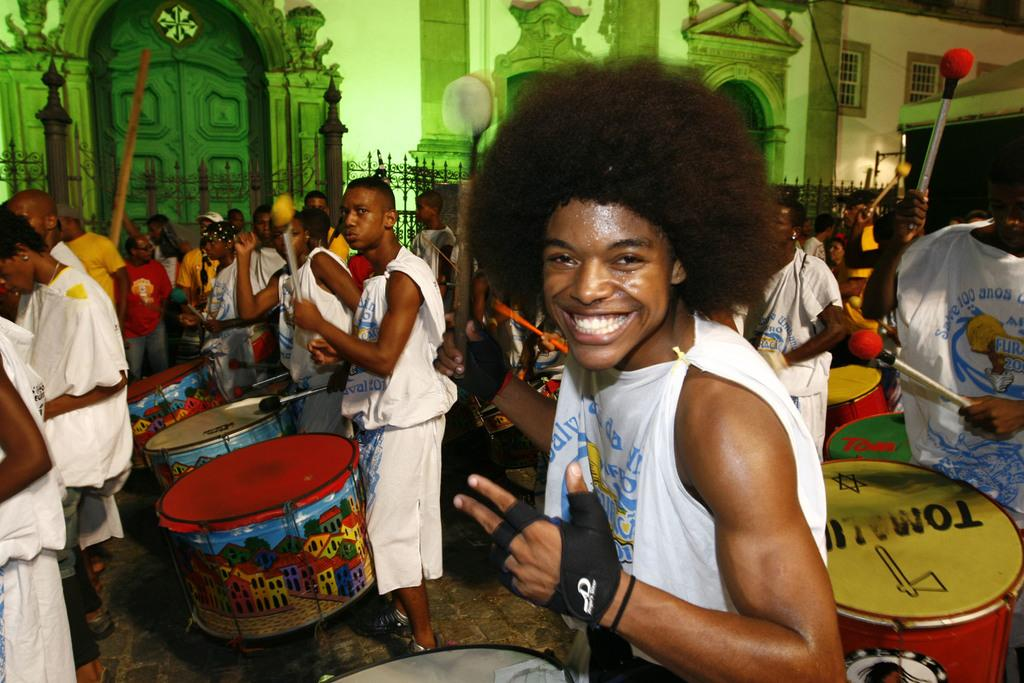What type of structure can be seen in the background of the image? There is a house with windows in the background. What is a prominent feature of the house? There is a door visible in the image. What are the people in the image doing? The people are standing and playing drums. Where are the people located in relation to the building? The people are in front of a building. Can you tell me what type of prose the queen is reciting in the image? There is no queen or any prose recitation present in the image. What type of gate is visible in the image? There is no gate visible in the image. 